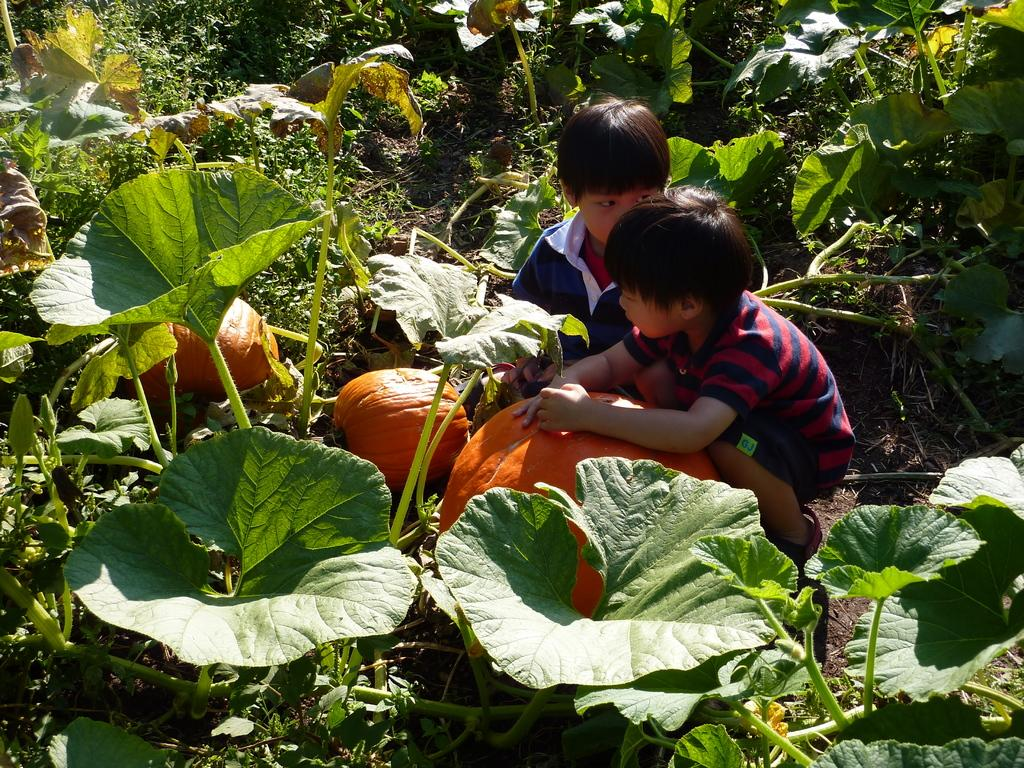How many kids are present in the image? There are two kids in the image. What objects are also visible in the image? There are pumpkins and plants visible in the image. What type of doll can be seen holding lettuce in the image? There is no doll present in the image, and therefore no such activity can be observed. 